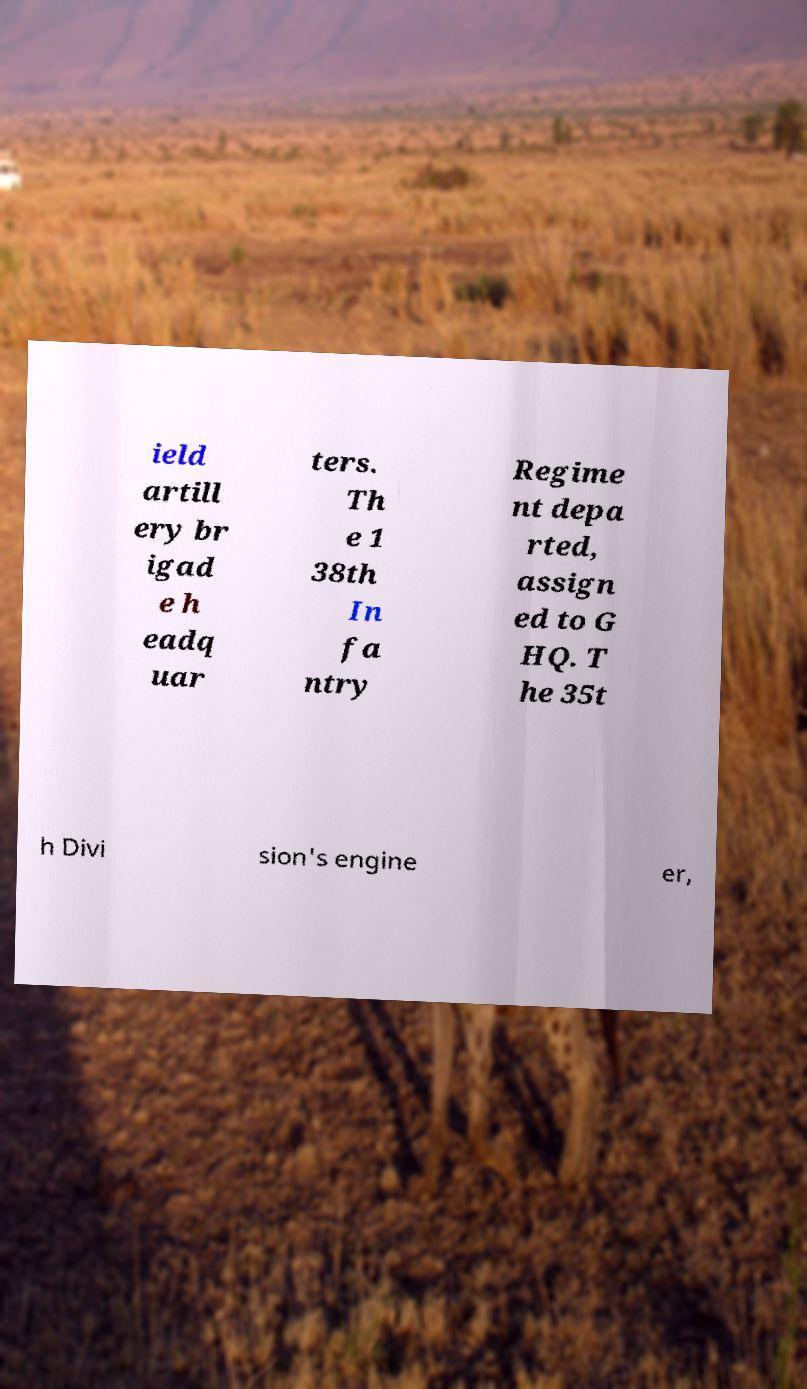What messages or text are displayed in this image? I need them in a readable, typed format. ield artill ery br igad e h eadq uar ters. Th e 1 38th In fa ntry Regime nt depa rted, assign ed to G HQ. T he 35t h Divi sion's engine er, 